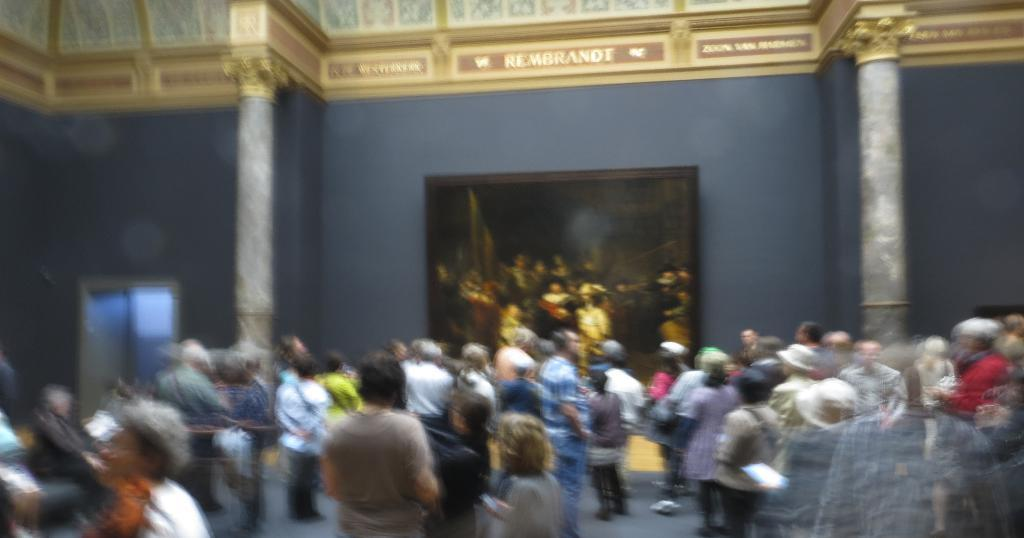What is happening in the image? There are persons standing in the image. Can you describe the background of the image? There is a photo frame attached to the wall in the background of the image. What type of plants are being used to make the stew in the image? There is no stew or plants present in the image; it only features persons standing and a photo frame on the wall. 